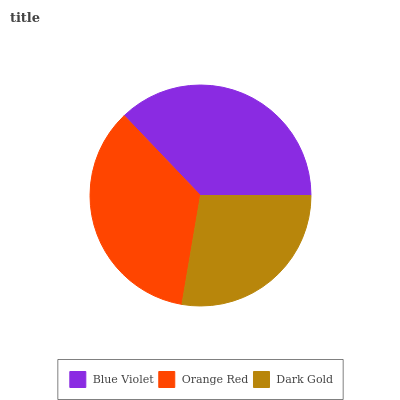Is Dark Gold the minimum?
Answer yes or no. Yes. Is Blue Violet the maximum?
Answer yes or no. Yes. Is Orange Red the minimum?
Answer yes or no. No. Is Orange Red the maximum?
Answer yes or no. No. Is Blue Violet greater than Orange Red?
Answer yes or no. Yes. Is Orange Red less than Blue Violet?
Answer yes or no. Yes. Is Orange Red greater than Blue Violet?
Answer yes or no. No. Is Blue Violet less than Orange Red?
Answer yes or no. No. Is Orange Red the high median?
Answer yes or no. Yes. Is Orange Red the low median?
Answer yes or no. Yes. Is Dark Gold the high median?
Answer yes or no. No. Is Dark Gold the low median?
Answer yes or no. No. 